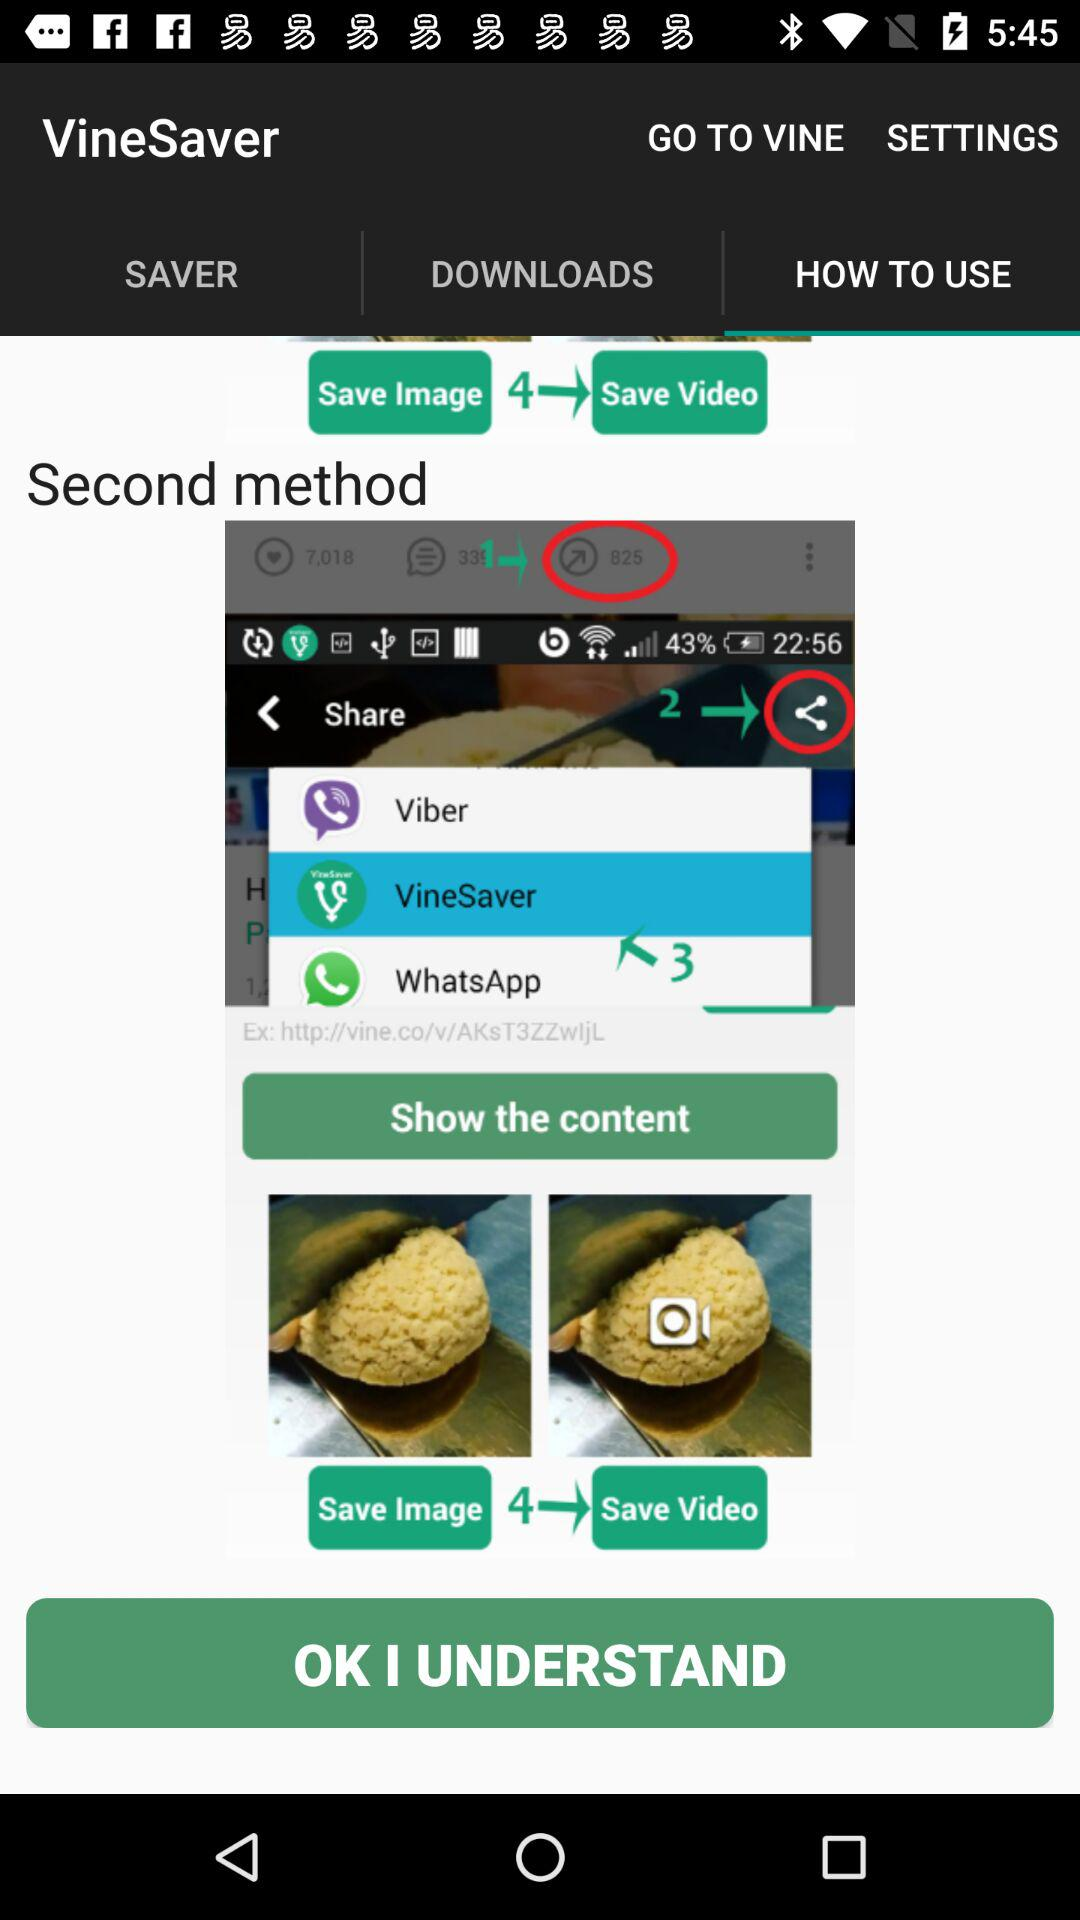What is the name of the application? The name of the application is "VineSaver". 